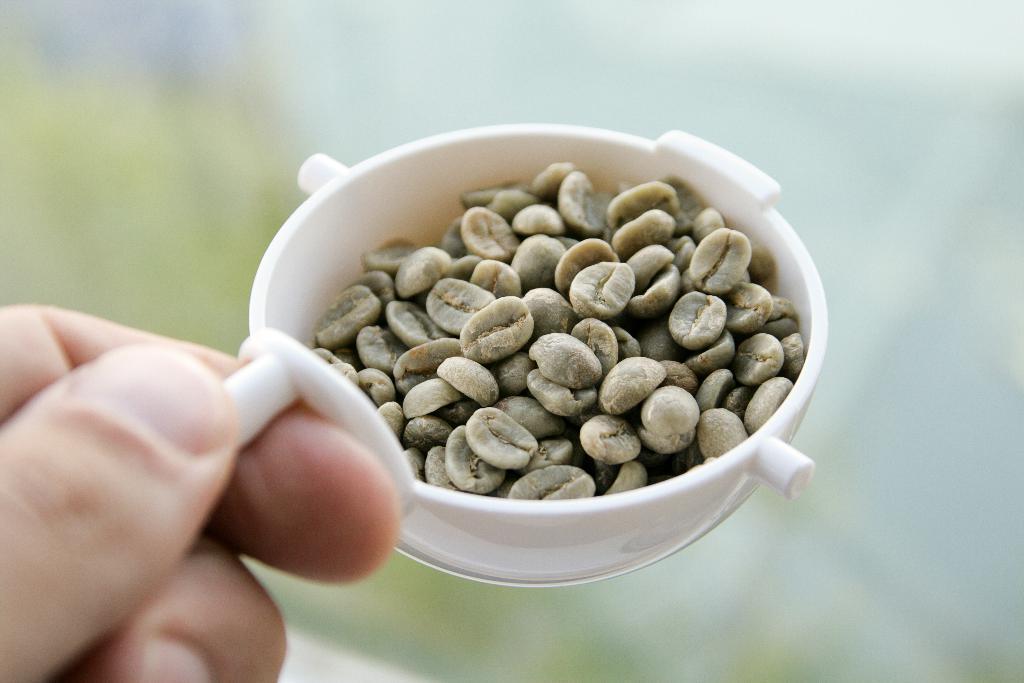Please provide a concise description of this image. In this image I can see a person holding a bowl. I can see few seeds in the bowl. 